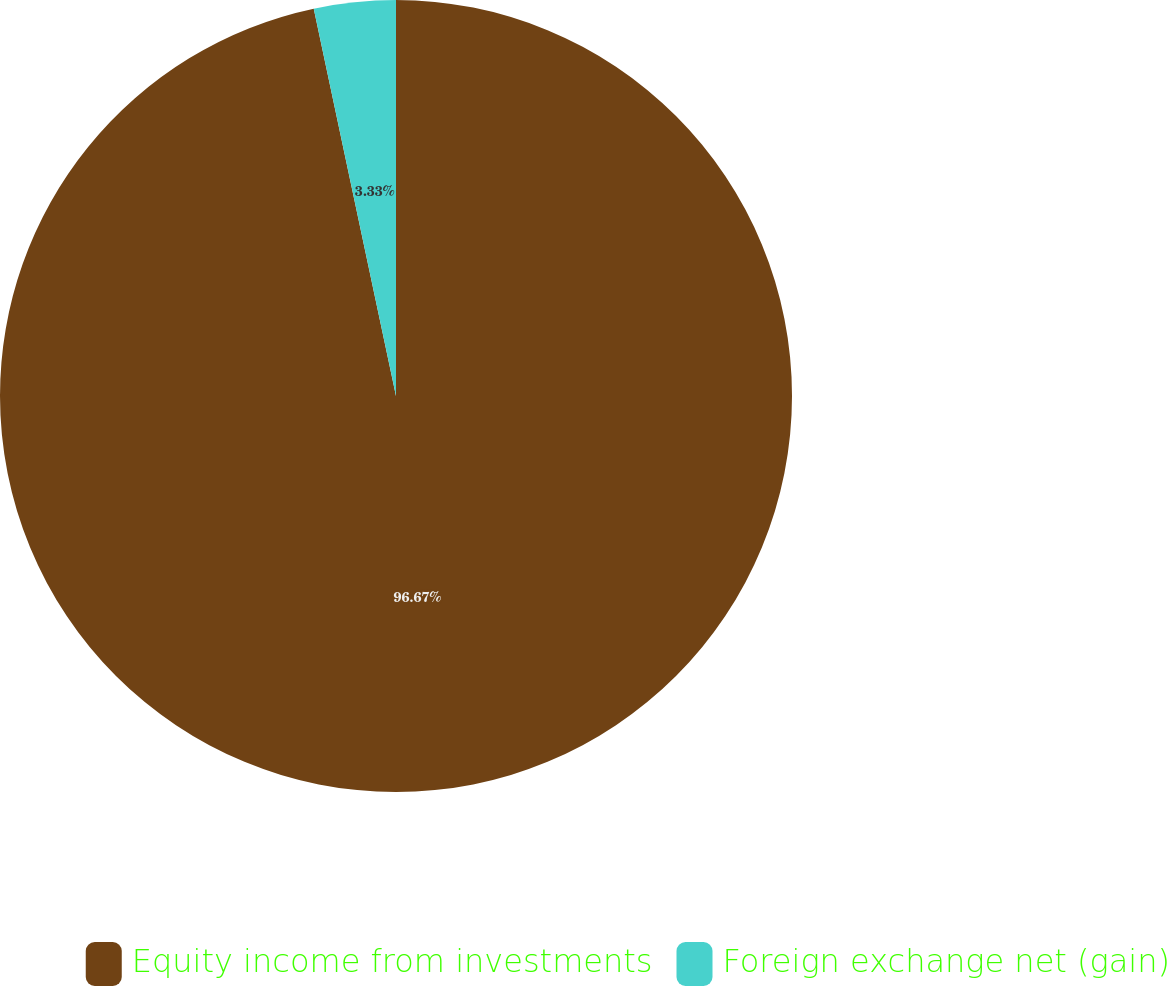Convert chart. <chart><loc_0><loc_0><loc_500><loc_500><pie_chart><fcel>Equity income from investments<fcel>Foreign exchange net (gain)<nl><fcel>96.67%<fcel>3.33%<nl></chart> 